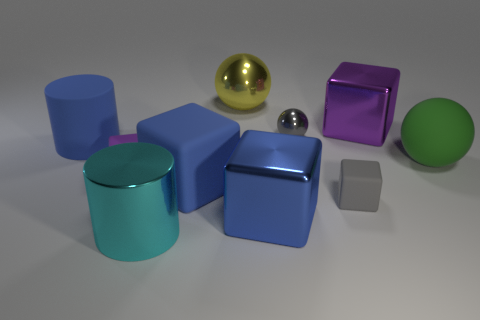Are there the same number of cyan metallic things behind the gray metallic object and big green rubber things?
Make the answer very short. No. What size is the object that is the same color as the small sphere?
Your answer should be compact. Small. Is the shape of the gray shiny thing the same as the large blue metal thing?
Provide a succinct answer. No. What number of objects are rubber objects that are on the left side of the green matte object or tiny purple matte cubes?
Ensure brevity in your answer.  4. Are there the same number of balls behind the yellow metal ball and tiny gray cubes on the left side of the large cyan cylinder?
Offer a terse response. Yes. What number of other objects are there of the same shape as the small gray rubber object?
Provide a succinct answer. 4. There is a blue matte thing that is right of the big cyan cylinder; does it have the same size as the block behind the green ball?
Provide a succinct answer. Yes. How many spheres are large cyan metal objects or blue metallic things?
Keep it short and to the point. 0. How many shiny objects are either large green cubes or small gray things?
Offer a terse response. 1. What size is the rubber object that is the same shape as the large cyan shiny object?
Keep it short and to the point. Large. 